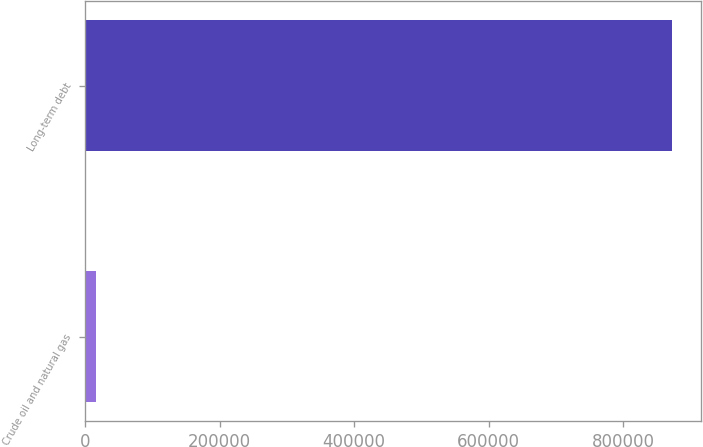<chart> <loc_0><loc_0><loc_500><loc_500><bar_chart><fcel>Crude oil and natural gas<fcel>Long-term debt<nl><fcel>16032<fcel>871540<nl></chart> 